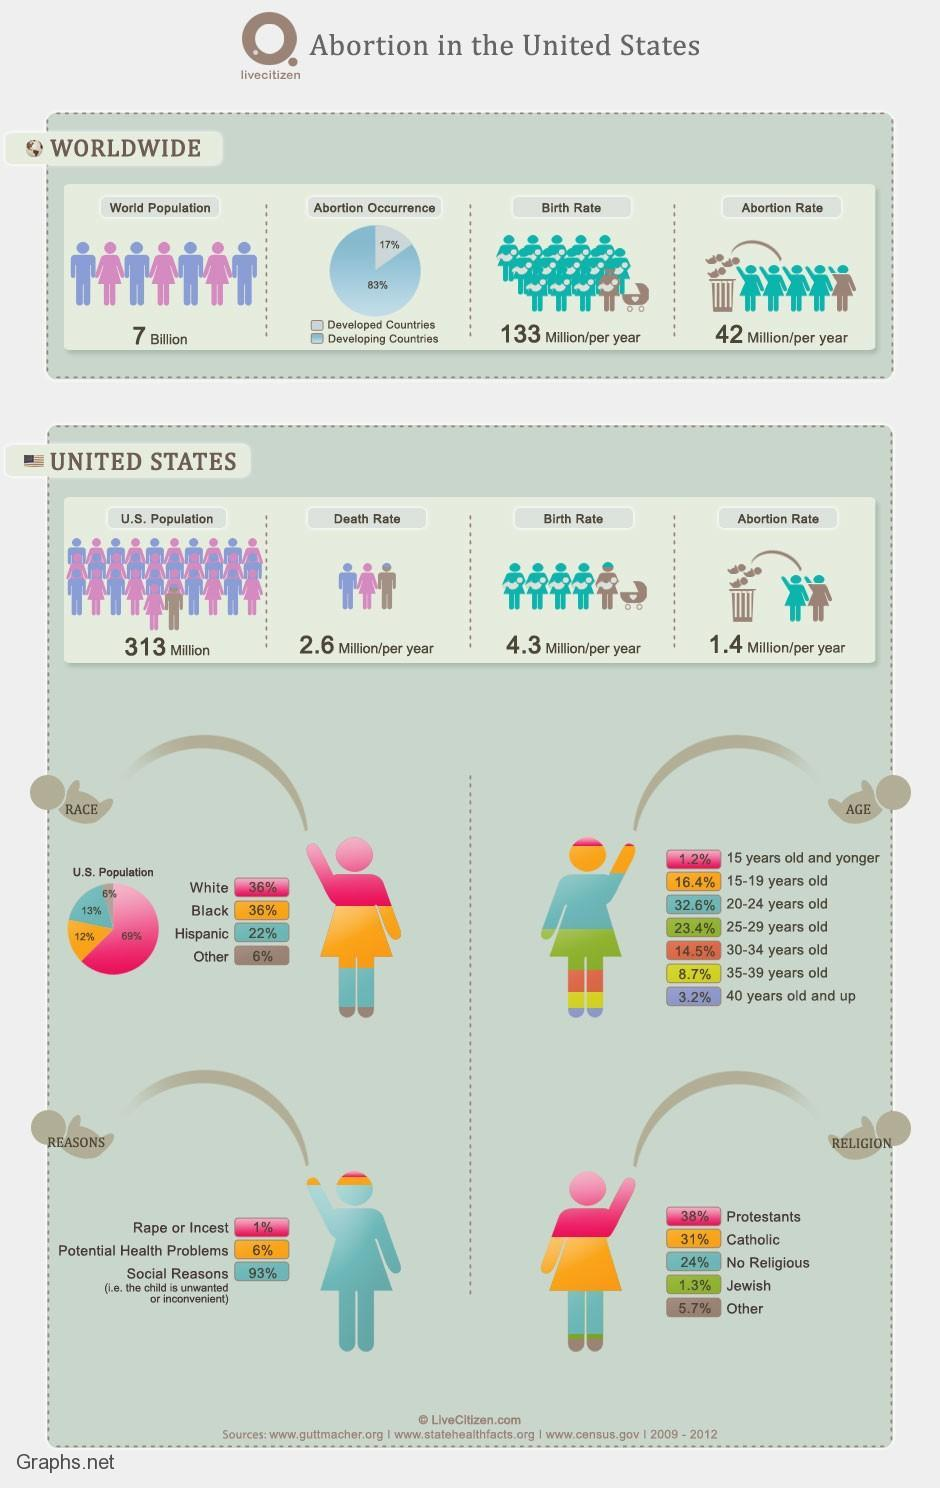what is the difference between US death rate and birth rate per year
Answer the question with a short phrase. 1.7 which countries are abortion percentage higher developing countries what is the abortion percentage for age below 20 years 17.6 what is the abortion percentage for catholic and jewish religion 32.3 what is the second common reason for abortions potential health problems what is the difference between birth rate of the world and US 128.7 